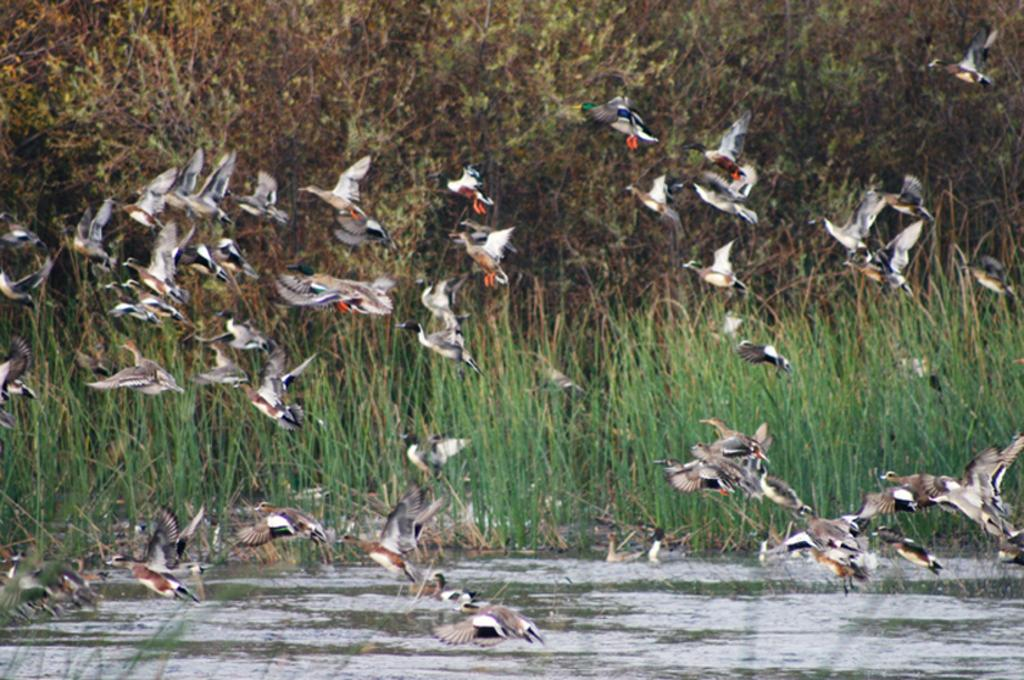What type of natural environment is depicted in the image? The image features water, grass, and trees, which suggests a natural environment. What type of animals can be seen in the image? There are birds in the image. What is the primary color of the grass in the image? The grass in the image is green. Can you see any dogs smiling in the image? There are no dogs or smiles present in the image. 